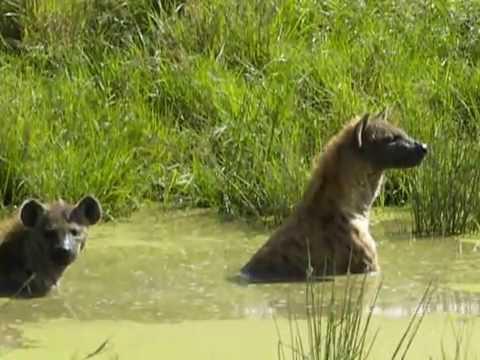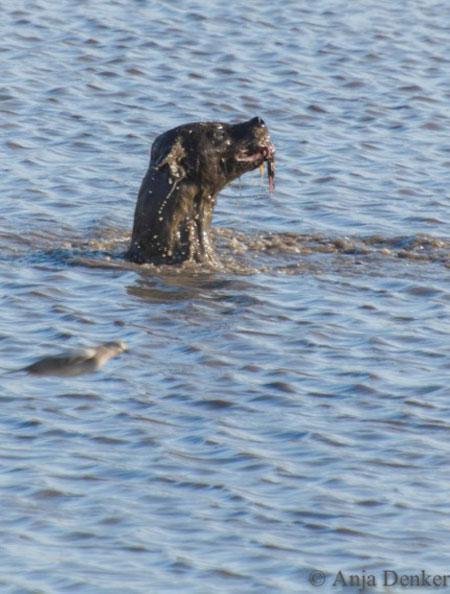The first image is the image on the left, the second image is the image on the right. Examine the images to the left and right. Is the description "There are at least two hyenas in the water in the image on the right." accurate? Answer yes or no. No. The first image is the image on the left, the second image is the image on the right. Assess this claim about the two images: "An image shows at least three hyenas in the water.". Correct or not? Answer yes or no. No. 